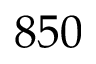Convert formula to latex. <formula><loc_0><loc_0><loc_500><loc_500>8 5 0</formula> 